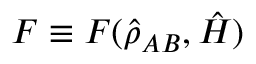<formula> <loc_0><loc_0><loc_500><loc_500>F \equiv F ( \hat { \rho } _ { A B } , \hat { H } )</formula> 